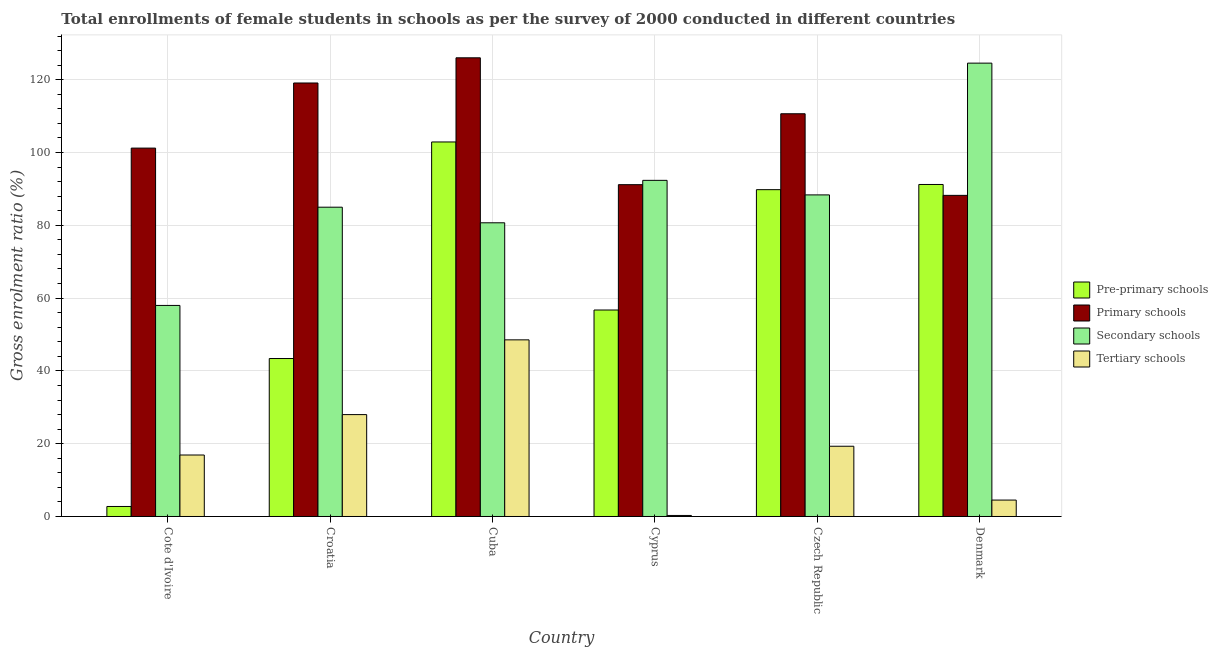How many bars are there on the 5th tick from the right?
Make the answer very short. 4. What is the label of the 4th group of bars from the left?
Offer a terse response. Cyprus. In how many cases, is the number of bars for a given country not equal to the number of legend labels?
Give a very brief answer. 0. What is the gross enrolment ratio(female) in primary schools in Denmark?
Provide a short and direct response. 88.23. Across all countries, what is the maximum gross enrolment ratio(female) in tertiary schools?
Offer a terse response. 48.53. Across all countries, what is the minimum gross enrolment ratio(female) in primary schools?
Your answer should be compact. 88.23. In which country was the gross enrolment ratio(female) in tertiary schools maximum?
Make the answer very short. Cuba. In which country was the gross enrolment ratio(female) in pre-primary schools minimum?
Offer a very short reply. Cote d'Ivoire. What is the total gross enrolment ratio(female) in pre-primary schools in the graph?
Give a very brief answer. 386.79. What is the difference between the gross enrolment ratio(female) in tertiary schools in Cote d'Ivoire and that in Cyprus?
Make the answer very short. 16.61. What is the difference between the gross enrolment ratio(female) in primary schools in Croatia and the gross enrolment ratio(female) in pre-primary schools in Cote d'Ivoire?
Ensure brevity in your answer.  116.36. What is the average gross enrolment ratio(female) in primary schools per country?
Your answer should be very brief. 106.07. What is the difference between the gross enrolment ratio(female) in tertiary schools and gross enrolment ratio(female) in pre-primary schools in Cyprus?
Keep it short and to the point. -56.45. What is the ratio of the gross enrolment ratio(female) in primary schools in Cote d'Ivoire to that in Croatia?
Offer a very short reply. 0.85. What is the difference between the highest and the second highest gross enrolment ratio(female) in secondary schools?
Give a very brief answer. 32.2. What is the difference between the highest and the lowest gross enrolment ratio(female) in tertiary schools?
Give a very brief answer. 48.25. Is the sum of the gross enrolment ratio(female) in pre-primary schools in Cuba and Denmark greater than the maximum gross enrolment ratio(female) in tertiary schools across all countries?
Your answer should be very brief. Yes. Is it the case that in every country, the sum of the gross enrolment ratio(female) in pre-primary schools and gross enrolment ratio(female) in secondary schools is greater than the sum of gross enrolment ratio(female) in tertiary schools and gross enrolment ratio(female) in primary schools?
Make the answer very short. No. What does the 3rd bar from the left in Croatia represents?
Your response must be concise. Secondary schools. What does the 3rd bar from the right in Cuba represents?
Give a very brief answer. Primary schools. How many bars are there?
Make the answer very short. 24. How many countries are there in the graph?
Ensure brevity in your answer.  6. What is the difference between two consecutive major ticks on the Y-axis?
Your answer should be very brief. 20. Are the values on the major ticks of Y-axis written in scientific E-notation?
Make the answer very short. No. Does the graph contain any zero values?
Your answer should be very brief. No. Does the graph contain grids?
Keep it short and to the point. Yes. How are the legend labels stacked?
Offer a very short reply. Vertical. What is the title of the graph?
Keep it short and to the point. Total enrollments of female students in schools as per the survey of 2000 conducted in different countries. Does "WFP" appear as one of the legend labels in the graph?
Ensure brevity in your answer.  No. What is the label or title of the X-axis?
Provide a succinct answer. Country. What is the Gross enrolment ratio (%) of Pre-primary schools in Cote d'Ivoire?
Provide a short and direct response. 2.75. What is the Gross enrolment ratio (%) of Primary schools in Cote d'Ivoire?
Keep it short and to the point. 101.21. What is the Gross enrolment ratio (%) in Secondary schools in Cote d'Ivoire?
Keep it short and to the point. 57.99. What is the Gross enrolment ratio (%) of Tertiary schools in Cote d'Ivoire?
Provide a succinct answer. 16.89. What is the Gross enrolment ratio (%) in Pre-primary schools in Croatia?
Make the answer very short. 43.4. What is the Gross enrolment ratio (%) of Primary schools in Croatia?
Keep it short and to the point. 119.11. What is the Gross enrolment ratio (%) in Secondary schools in Croatia?
Make the answer very short. 84.98. What is the Gross enrolment ratio (%) in Tertiary schools in Croatia?
Keep it short and to the point. 27.99. What is the Gross enrolment ratio (%) of Pre-primary schools in Cuba?
Make the answer very short. 102.9. What is the Gross enrolment ratio (%) of Primary schools in Cuba?
Your answer should be very brief. 126.02. What is the Gross enrolment ratio (%) of Secondary schools in Cuba?
Give a very brief answer. 80.69. What is the Gross enrolment ratio (%) in Tertiary schools in Cuba?
Offer a terse response. 48.53. What is the Gross enrolment ratio (%) of Pre-primary schools in Cyprus?
Give a very brief answer. 56.73. What is the Gross enrolment ratio (%) of Primary schools in Cyprus?
Give a very brief answer. 91.17. What is the Gross enrolment ratio (%) in Secondary schools in Cyprus?
Make the answer very short. 92.35. What is the Gross enrolment ratio (%) of Tertiary schools in Cyprus?
Your response must be concise. 0.28. What is the Gross enrolment ratio (%) of Pre-primary schools in Czech Republic?
Your answer should be compact. 89.8. What is the Gross enrolment ratio (%) of Primary schools in Czech Republic?
Make the answer very short. 110.65. What is the Gross enrolment ratio (%) of Secondary schools in Czech Republic?
Your answer should be very brief. 88.36. What is the Gross enrolment ratio (%) in Tertiary schools in Czech Republic?
Ensure brevity in your answer.  19.3. What is the Gross enrolment ratio (%) in Pre-primary schools in Denmark?
Your answer should be compact. 91.22. What is the Gross enrolment ratio (%) in Primary schools in Denmark?
Give a very brief answer. 88.23. What is the Gross enrolment ratio (%) of Secondary schools in Denmark?
Keep it short and to the point. 124.56. What is the Gross enrolment ratio (%) of Tertiary schools in Denmark?
Ensure brevity in your answer.  4.51. Across all countries, what is the maximum Gross enrolment ratio (%) of Pre-primary schools?
Offer a terse response. 102.9. Across all countries, what is the maximum Gross enrolment ratio (%) of Primary schools?
Offer a terse response. 126.02. Across all countries, what is the maximum Gross enrolment ratio (%) of Secondary schools?
Give a very brief answer. 124.56. Across all countries, what is the maximum Gross enrolment ratio (%) of Tertiary schools?
Provide a succinct answer. 48.53. Across all countries, what is the minimum Gross enrolment ratio (%) of Pre-primary schools?
Offer a very short reply. 2.75. Across all countries, what is the minimum Gross enrolment ratio (%) of Primary schools?
Make the answer very short. 88.23. Across all countries, what is the minimum Gross enrolment ratio (%) of Secondary schools?
Your answer should be very brief. 57.99. Across all countries, what is the minimum Gross enrolment ratio (%) in Tertiary schools?
Offer a terse response. 0.28. What is the total Gross enrolment ratio (%) in Pre-primary schools in the graph?
Provide a succinct answer. 386.79. What is the total Gross enrolment ratio (%) of Primary schools in the graph?
Offer a very short reply. 636.39. What is the total Gross enrolment ratio (%) of Secondary schools in the graph?
Offer a terse response. 528.93. What is the total Gross enrolment ratio (%) of Tertiary schools in the graph?
Provide a short and direct response. 117.51. What is the difference between the Gross enrolment ratio (%) of Pre-primary schools in Cote d'Ivoire and that in Croatia?
Offer a terse response. -40.65. What is the difference between the Gross enrolment ratio (%) of Primary schools in Cote d'Ivoire and that in Croatia?
Provide a succinct answer. -17.89. What is the difference between the Gross enrolment ratio (%) in Secondary schools in Cote d'Ivoire and that in Croatia?
Offer a terse response. -26.99. What is the difference between the Gross enrolment ratio (%) of Tertiary schools in Cote d'Ivoire and that in Croatia?
Your answer should be very brief. -11.1. What is the difference between the Gross enrolment ratio (%) in Pre-primary schools in Cote d'Ivoire and that in Cuba?
Ensure brevity in your answer.  -100.15. What is the difference between the Gross enrolment ratio (%) of Primary schools in Cote d'Ivoire and that in Cuba?
Offer a very short reply. -24.81. What is the difference between the Gross enrolment ratio (%) in Secondary schools in Cote d'Ivoire and that in Cuba?
Your response must be concise. -22.71. What is the difference between the Gross enrolment ratio (%) of Tertiary schools in Cote d'Ivoire and that in Cuba?
Offer a terse response. -31.64. What is the difference between the Gross enrolment ratio (%) in Pre-primary schools in Cote d'Ivoire and that in Cyprus?
Your answer should be very brief. -53.98. What is the difference between the Gross enrolment ratio (%) in Primary schools in Cote d'Ivoire and that in Cyprus?
Your answer should be compact. 10.05. What is the difference between the Gross enrolment ratio (%) of Secondary schools in Cote d'Ivoire and that in Cyprus?
Keep it short and to the point. -34.37. What is the difference between the Gross enrolment ratio (%) of Tertiary schools in Cote d'Ivoire and that in Cyprus?
Your answer should be very brief. 16.61. What is the difference between the Gross enrolment ratio (%) of Pre-primary schools in Cote d'Ivoire and that in Czech Republic?
Your answer should be very brief. -87.05. What is the difference between the Gross enrolment ratio (%) of Primary schools in Cote d'Ivoire and that in Czech Republic?
Provide a succinct answer. -9.44. What is the difference between the Gross enrolment ratio (%) in Secondary schools in Cote d'Ivoire and that in Czech Republic?
Make the answer very short. -30.37. What is the difference between the Gross enrolment ratio (%) of Tertiary schools in Cote d'Ivoire and that in Czech Republic?
Ensure brevity in your answer.  -2.41. What is the difference between the Gross enrolment ratio (%) of Pre-primary schools in Cote d'Ivoire and that in Denmark?
Your answer should be very brief. -88.47. What is the difference between the Gross enrolment ratio (%) of Primary schools in Cote d'Ivoire and that in Denmark?
Your response must be concise. 12.98. What is the difference between the Gross enrolment ratio (%) of Secondary schools in Cote d'Ivoire and that in Denmark?
Your response must be concise. -66.57. What is the difference between the Gross enrolment ratio (%) of Tertiary schools in Cote d'Ivoire and that in Denmark?
Provide a short and direct response. 12.38. What is the difference between the Gross enrolment ratio (%) of Pre-primary schools in Croatia and that in Cuba?
Make the answer very short. -59.5. What is the difference between the Gross enrolment ratio (%) of Primary schools in Croatia and that in Cuba?
Your answer should be very brief. -6.92. What is the difference between the Gross enrolment ratio (%) of Secondary schools in Croatia and that in Cuba?
Your answer should be very brief. 4.28. What is the difference between the Gross enrolment ratio (%) in Tertiary schools in Croatia and that in Cuba?
Your answer should be very brief. -20.54. What is the difference between the Gross enrolment ratio (%) in Pre-primary schools in Croatia and that in Cyprus?
Make the answer very short. -13.33. What is the difference between the Gross enrolment ratio (%) of Primary schools in Croatia and that in Cyprus?
Give a very brief answer. 27.94. What is the difference between the Gross enrolment ratio (%) of Secondary schools in Croatia and that in Cyprus?
Keep it short and to the point. -7.38. What is the difference between the Gross enrolment ratio (%) in Tertiary schools in Croatia and that in Cyprus?
Ensure brevity in your answer.  27.71. What is the difference between the Gross enrolment ratio (%) of Pre-primary schools in Croatia and that in Czech Republic?
Ensure brevity in your answer.  -46.39. What is the difference between the Gross enrolment ratio (%) of Primary schools in Croatia and that in Czech Republic?
Your answer should be compact. 8.45. What is the difference between the Gross enrolment ratio (%) of Secondary schools in Croatia and that in Czech Republic?
Your answer should be very brief. -3.38. What is the difference between the Gross enrolment ratio (%) in Tertiary schools in Croatia and that in Czech Republic?
Ensure brevity in your answer.  8.7. What is the difference between the Gross enrolment ratio (%) of Pre-primary schools in Croatia and that in Denmark?
Provide a short and direct response. -47.82. What is the difference between the Gross enrolment ratio (%) of Primary schools in Croatia and that in Denmark?
Your response must be concise. 30.88. What is the difference between the Gross enrolment ratio (%) of Secondary schools in Croatia and that in Denmark?
Ensure brevity in your answer.  -39.58. What is the difference between the Gross enrolment ratio (%) in Tertiary schools in Croatia and that in Denmark?
Provide a short and direct response. 23.48. What is the difference between the Gross enrolment ratio (%) of Pre-primary schools in Cuba and that in Cyprus?
Give a very brief answer. 46.17. What is the difference between the Gross enrolment ratio (%) of Primary schools in Cuba and that in Cyprus?
Offer a terse response. 34.86. What is the difference between the Gross enrolment ratio (%) of Secondary schools in Cuba and that in Cyprus?
Offer a terse response. -11.66. What is the difference between the Gross enrolment ratio (%) of Tertiary schools in Cuba and that in Cyprus?
Your answer should be compact. 48.25. What is the difference between the Gross enrolment ratio (%) of Pre-primary schools in Cuba and that in Czech Republic?
Provide a succinct answer. 13.1. What is the difference between the Gross enrolment ratio (%) in Primary schools in Cuba and that in Czech Republic?
Make the answer very short. 15.37. What is the difference between the Gross enrolment ratio (%) in Secondary schools in Cuba and that in Czech Republic?
Your answer should be very brief. -7.66. What is the difference between the Gross enrolment ratio (%) in Tertiary schools in Cuba and that in Czech Republic?
Provide a short and direct response. 29.23. What is the difference between the Gross enrolment ratio (%) in Pre-primary schools in Cuba and that in Denmark?
Offer a very short reply. 11.68. What is the difference between the Gross enrolment ratio (%) of Primary schools in Cuba and that in Denmark?
Your answer should be very brief. 37.79. What is the difference between the Gross enrolment ratio (%) of Secondary schools in Cuba and that in Denmark?
Your answer should be compact. -43.86. What is the difference between the Gross enrolment ratio (%) in Tertiary schools in Cuba and that in Denmark?
Ensure brevity in your answer.  44.02. What is the difference between the Gross enrolment ratio (%) in Pre-primary schools in Cyprus and that in Czech Republic?
Make the answer very short. -33.06. What is the difference between the Gross enrolment ratio (%) of Primary schools in Cyprus and that in Czech Republic?
Offer a very short reply. -19.48. What is the difference between the Gross enrolment ratio (%) of Secondary schools in Cyprus and that in Czech Republic?
Your answer should be very brief. 4. What is the difference between the Gross enrolment ratio (%) of Tertiary schools in Cyprus and that in Czech Republic?
Ensure brevity in your answer.  -19.02. What is the difference between the Gross enrolment ratio (%) of Pre-primary schools in Cyprus and that in Denmark?
Ensure brevity in your answer.  -34.49. What is the difference between the Gross enrolment ratio (%) of Primary schools in Cyprus and that in Denmark?
Give a very brief answer. 2.94. What is the difference between the Gross enrolment ratio (%) of Secondary schools in Cyprus and that in Denmark?
Offer a very short reply. -32.2. What is the difference between the Gross enrolment ratio (%) of Tertiary schools in Cyprus and that in Denmark?
Your response must be concise. -4.23. What is the difference between the Gross enrolment ratio (%) of Pre-primary schools in Czech Republic and that in Denmark?
Give a very brief answer. -1.42. What is the difference between the Gross enrolment ratio (%) of Primary schools in Czech Republic and that in Denmark?
Your response must be concise. 22.42. What is the difference between the Gross enrolment ratio (%) in Secondary schools in Czech Republic and that in Denmark?
Your answer should be very brief. -36.2. What is the difference between the Gross enrolment ratio (%) of Tertiary schools in Czech Republic and that in Denmark?
Provide a short and direct response. 14.79. What is the difference between the Gross enrolment ratio (%) in Pre-primary schools in Cote d'Ivoire and the Gross enrolment ratio (%) in Primary schools in Croatia?
Offer a terse response. -116.36. What is the difference between the Gross enrolment ratio (%) of Pre-primary schools in Cote d'Ivoire and the Gross enrolment ratio (%) of Secondary schools in Croatia?
Keep it short and to the point. -82.23. What is the difference between the Gross enrolment ratio (%) of Pre-primary schools in Cote d'Ivoire and the Gross enrolment ratio (%) of Tertiary schools in Croatia?
Make the answer very short. -25.25. What is the difference between the Gross enrolment ratio (%) in Primary schools in Cote d'Ivoire and the Gross enrolment ratio (%) in Secondary schools in Croatia?
Make the answer very short. 16.24. What is the difference between the Gross enrolment ratio (%) in Primary schools in Cote d'Ivoire and the Gross enrolment ratio (%) in Tertiary schools in Croatia?
Keep it short and to the point. 73.22. What is the difference between the Gross enrolment ratio (%) of Secondary schools in Cote d'Ivoire and the Gross enrolment ratio (%) of Tertiary schools in Croatia?
Give a very brief answer. 29.99. What is the difference between the Gross enrolment ratio (%) of Pre-primary schools in Cote d'Ivoire and the Gross enrolment ratio (%) of Primary schools in Cuba?
Your answer should be very brief. -123.27. What is the difference between the Gross enrolment ratio (%) in Pre-primary schools in Cote d'Ivoire and the Gross enrolment ratio (%) in Secondary schools in Cuba?
Offer a very short reply. -77.95. What is the difference between the Gross enrolment ratio (%) in Pre-primary schools in Cote d'Ivoire and the Gross enrolment ratio (%) in Tertiary schools in Cuba?
Your answer should be compact. -45.78. What is the difference between the Gross enrolment ratio (%) in Primary schools in Cote d'Ivoire and the Gross enrolment ratio (%) in Secondary schools in Cuba?
Your response must be concise. 20.52. What is the difference between the Gross enrolment ratio (%) in Primary schools in Cote d'Ivoire and the Gross enrolment ratio (%) in Tertiary schools in Cuba?
Your response must be concise. 52.68. What is the difference between the Gross enrolment ratio (%) in Secondary schools in Cote d'Ivoire and the Gross enrolment ratio (%) in Tertiary schools in Cuba?
Ensure brevity in your answer.  9.46. What is the difference between the Gross enrolment ratio (%) in Pre-primary schools in Cote d'Ivoire and the Gross enrolment ratio (%) in Primary schools in Cyprus?
Ensure brevity in your answer.  -88.42. What is the difference between the Gross enrolment ratio (%) of Pre-primary schools in Cote d'Ivoire and the Gross enrolment ratio (%) of Secondary schools in Cyprus?
Offer a terse response. -89.61. What is the difference between the Gross enrolment ratio (%) of Pre-primary schools in Cote d'Ivoire and the Gross enrolment ratio (%) of Tertiary schools in Cyprus?
Provide a short and direct response. 2.47. What is the difference between the Gross enrolment ratio (%) of Primary schools in Cote d'Ivoire and the Gross enrolment ratio (%) of Secondary schools in Cyprus?
Offer a very short reply. 8.86. What is the difference between the Gross enrolment ratio (%) of Primary schools in Cote d'Ivoire and the Gross enrolment ratio (%) of Tertiary schools in Cyprus?
Give a very brief answer. 100.93. What is the difference between the Gross enrolment ratio (%) in Secondary schools in Cote d'Ivoire and the Gross enrolment ratio (%) in Tertiary schools in Cyprus?
Offer a terse response. 57.71. What is the difference between the Gross enrolment ratio (%) of Pre-primary schools in Cote d'Ivoire and the Gross enrolment ratio (%) of Primary schools in Czech Republic?
Ensure brevity in your answer.  -107.9. What is the difference between the Gross enrolment ratio (%) in Pre-primary schools in Cote d'Ivoire and the Gross enrolment ratio (%) in Secondary schools in Czech Republic?
Keep it short and to the point. -85.61. What is the difference between the Gross enrolment ratio (%) in Pre-primary schools in Cote d'Ivoire and the Gross enrolment ratio (%) in Tertiary schools in Czech Republic?
Ensure brevity in your answer.  -16.55. What is the difference between the Gross enrolment ratio (%) in Primary schools in Cote d'Ivoire and the Gross enrolment ratio (%) in Secondary schools in Czech Republic?
Provide a succinct answer. 12.86. What is the difference between the Gross enrolment ratio (%) of Primary schools in Cote d'Ivoire and the Gross enrolment ratio (%) of Tertiary schools in Czech Republic?
Provide a succinct answer. 81.92. What is the difference between the Gross enrolment ratio (%) in Secondary schools in Cote d'Ivoire and the Gross enrolment ratio (%) in Tertiary schools in Czech Republic?
Give a very brief answer. 38.69. What is the difference between the Gross enrolment ratio (%) in Pre-primary schools in Cote d'Ivoire and the Gross enrolment ratio (%) in Primary schools in Denmark?
Provide a succinct answer. -85.48. What is the difference between the Gross enrolment ratio (%) of Pre-primary schools in Cote d'Ivoire and the Gross enrolment ratio (%) of Secondary schools in Denmark?
Offer a very short reply. -121.81. What is the difference between the Gross enrolment ratio (%) in Pre-primary schools in Cote d'Ivoire and the Gross enrolment ratio (%) in Tertiary schools in Denmark?
Give a very brief answer. -1.76. What is the difference between the Gross enrolment ratio (%) in Primary schools in Cote d'Ivoire and the Gross enrolment ratio (%) in Secondary schools in Denmark?
Your response must be concise. -23.34. What is the difference between the Gross enrolment ratio (%) of Primary schools in Cote d'Ivoire and the Gross enrolment ratio (%) of Tertiary schools in Denmark?
Offer a very short reply. 96.7. What is the difference between the Gross enrolment ratio (%) of Secondary schools in Cote d'Ivoire and the Gross enrolment ratio (%) of Tertiary schools in Denmark?
Your response must be concise. 53.48. What is the difference between the Gross enrolment ratio (%) in Pre-primary schools in Croatia and the Gross enrolment ratio (%) in Primary schools in Cuba?
Your response must be concise. -82.62. What is the difference between the Gross enrolment ratio (%) in Pre-primary schools in Croatia and the Gross enrolment ratio (%) in Secondary schools in Cuba?
Keep it short and to the point. -37.29. What is the difference between the Gross enrolment ratio (%) of Pre-primary schools in Croatia and the Gross enrolment ratio (%) of Tertiary schools in Cuba?
Give a very brief answer. -5.13. What is the difference between the Gross enrolment ratio (%) of Primary schools in Croatia and the Gross enrolment ratio (%) of Secondary schools in Cuba?
Your response must be concise. 38.41. What is the difference between the Gross enrolment ratio (%) in Primary schools in Croatia and the Gross enrolment ratio (%) in Tertiary schools in Cuba?
Offer a terse response. 70.57. What is the difference between the Gross enrolment ratio (%) of Secondary schools in Croatia and the Gross enrolment ratio (%) of Tertiary schools in Cuba?
Offer a terse response. 36.45. What is the difference between the Gross enrolment ratio (%) in Pre-primary schools in Croatia and the Gross enrolment ratio (%) in Primary schools in Cyprus?
Your response must be concise. -47.77. What is the difference between the Gross enrolment ratio (%) of Pre-primary schools in Croatia and the Gross enrolment ratio (%) of Secondary schools in Cyprus?
Your answer should be very brief. -48.95. What is the difference between the Gross enrolment ratio (%) in Pre-primary schools in Croatia and the Gross enrolment ratio (%) in Tertiary schools in Cyprus?
Ensure brevity in your answer.  43.12. What is the difference between the Gross enrolment ratio (%) in Primary schools in Croatia and the Gross enrolment ratio (%) in Secondary schools in Cyprus?
Offer a very short reply. 26.75. What is the difference between the Gross enrolment ratio (%) in Primary schools in Croatia and the Gross enrolment ratio (%) in Tertiary schools in Cyprus?
Offer a very short reply. 118.82. What is the difference between the Gross enrolment ratio (%) in Secondary schools in Croatia and the Gross enrolment ratio (%) in Tertiary schools in Cyprus?
Your answer should be very brief. 84.7. What is the difference between the Gross enrolment ratio (%) of Pre-primary schools in Croatia and the Gross enrolment ratio (%) of Primary schools in Czech Republic?
Your answer should be very brief. -67.25. What is the difference between the Gross enrolment ratio (%) of Pre-primary schools in Croatia and the Gross enrolment ratio (%) of Secondary schools in Czech Republic?
Ensure brevity in your answer.  -44.96. What is the difference between the Gross enrolment ratio (%) of Pre-primary schools in Croatia and the Gross enrolment ratio (%) of Tertiary schools in Czech Republic?
Provide a succinct answer. 24.1. What is the difference between the Gross enrolment ratio (%) in Primary schools in Croatia and the Gross enrolment ratio (%) in Secondary schools in Czech Republic?
Offer a terse response. 30.75. What is the difference between the Gross enrolment ratio (%) in Primary schools in Croatia and the Gross enrolment ratio (%) in Tertiary schools in Czech Republic?
Give a very brief answer. 99.81. What is the difference between the Gross enrolment ratio (%) in Secondary schools in Croatia and the Gross enrolment ratio (%) in Tertiary schools in Czech Republic?
Ensure brevity in your answer.  65.68. What is the difference between the Gross enrolment ratio (%) of Pre-primary schools in Croatia and the Gross enrolment ratio (%) of Primary schools in Denmark?
Provide a succinct answer. -44.83. What is the difference between the Gross enrolment ratio (%) of Pre-primary schools in Croatia and the Gross enrolment ratio (%) of Secondary schools in Denmark?
Your answer should be very brief. -81.16. What is the difference between the Gross enrolment ratio (%) in Pre-primary schools in Croatia and the Gross enrolment ratio (%) in Tertiary schools in Denmark?
Your answer should be compact. 38.89. What is the difference between the Gross enrolment ratio (%) of Primary schools in Croatia and the Gross enrolment ratio (%) of Secondary schools in Denmark?
Give a very brief answer. -5.45. What is the difference between the Gross enrolment ratio (%) in Primary schools in Croatia and the Gross enrolment ratio (%) in Tertiary schools in Denmark?
Offer a terse response. 114.59. What is the difference between the Gross enrolment ratio (%) in Secondary schools in Croatia and the Gross enrolment ratio (%) in Tertiary schools in Denmark?
Your response must be concise. 80.47. What is the difference between the Gross enrolment ratio (%) in Pre-primary schools in Cuba and the Gross enrolment ratio (%) in Primary schools in Cyprus?
Provide a succinct answer. 11.73. What is the difference between the Gross enrolment ratio (%) of Pre-primary schools in Cuba and the Gross enrolment ratio (%) of Secondary schools in Cyprus?
Provide a short and direct response. 10.55. What is the difference between the Gross enrolment ratio (%) in Pre-primary schools in Cuba and the Gross enrolment ratio (%) in Tertiary schools in Cyprus?
Ensure brevity in your answer.  102.62. What is the difference between the Gross enrolment ratio (%) in Primary schools in Cuba and the Gross enrolment ratio (%) in Secondary schools in Cyprus?
Make the answer very short. 33.67. What is the difference between the Gross enrolment ratio (%) in Primary schools in Cuba and the Gross enrolment ratio (%) in Tertiary schools in Cyprus?
Offer a very short reply. 125.74. What is the difference between the Gross enrolment ratio (%) of Secondary schools in Cuba and the Gross enrolment ratio (%) of Tertiary schools in Cyprus?
Ensure brevity in your answer.  80.41. What is the difference between the Gross enrolment ratio (%) in Pre-primary schools in Cuba and the Gross enrolment ratio (%) in Primary schools in Czech Republic?
Your answer should be compact. -7.75. What is the difference between the Gross enrolment ratio (%) in Pre-primary schools in Cuba and the Gross enrolment ratio (%) in Secondary schools in Czech Republic?
Give a very brief answer. 14.54. What is the difference between the Gross enrolment ratio (%) in Pre-primary schools in Cuba and the Gross enrolment ratio (%) in Tertiary schools in Czech Republic?
Your answer should be very brief. 83.6. What is the difference between the Gross enrolment ratio (%) of Primary schools in Cuba and the Gross enrolment ratio (%) of Secondary schools in Czech Republic?
Keep it short and to the point. 37.67. What is the difference between the Gross enrolment ratio (%) of Primary schools in Cuba and the Gross enrolment ratio (%) of Tertiary schools in Czech Republic?
Make the answer very short. 106.72. What is the difference between the Gross enrolment ratio (%) of Secondary schools in Cuba and the Gross enrolment ratio (%) of Tertiary schools in Czech Republic?
Make the answer very short. 61.4. What is the difference between the Gross enrolment ratio (%) of Pre-primary schools in Cuba and the Gross enrolment ratio (%) of Primary schools in Denmark?
Your answer should be compact. 14.67. What is the difference between the Gross enrolment ratio (%) of Pre-primary schools in Cuba and the Gross enrolment ratio (%) of Secondary schools in Denmark?
Offer a terse response. -21.66. What is the difference between the Gross enrolment ratio (%) of Pre-primary schools in Cuba and the Gross enrolment ratio (%) of Tertiary schools in Denmark?
Offer a terse response. 98.39. What is the difference between the Gross enrolment ratio (%) in Primary schools in Cuba and the Gross enrolment ratio (%) in Secondary schools in Denmark?
Give a very brief answer. 1.46. What is the difference between the Gross enrolment ratio (%) in Primary schools in Cuba and the Gross enrolment ratio (%) in Tertiary schools in Denmark?
Make the answer very short. 121.51. What is the difference between the Gross enrolment ratio (%) of Secondary schools in Cuba and the Gross enrolment ratio (%) of Tertiary schools in Denmark?
Your response must be concise. 76.18. What is the difference between the Gross enrolment ratio (%) of Pre-primary schools in Cyprus and the Gross enrolment ratio (%) of Primary schools in Czech Republic?
Your response must be concise. -53.92. What is the difference between the Gross enrolment ratio (%) of Pre-primary schools in Cyprus and the Gross enrolment ratio (%) of Secondary schools in Czech Republic?
Give a very brief answer. -31.63. What is the difference between the Gross enrolment ratio (%) in Pre-primary schools in Cyprus and the Gross enrolment ratio (%) in Tertiary schools in Czech Republic?
Your answer should be compact. 37.43. What is the difference between the Gross enrolment ratio (%) in Primary schools in Cyprus and the Gross enrolment ratio (%) in Secondary schools in Czech Republic?
Ensure brevity in your answer.  2.81. What is the difference between the Gross enrolment ratio (%) of Primary schools in Cyprus and the Gross enrolment ratio (%) of Tertiary schools in Czech Republic?
Give a very brief answer. 71.87. What is the difference between the Gross enrolment ratio (%) of Secondary schools in Cyprus and the Gross enrolment ratio (%) of Tertiary schools in Czech Republic?
Provide a short and direct response. 73.05. What is the difference between the Gross enrolment ratio (%) in Pre-primary schools in Cyprus and the Gross enrolment ratio (%) in Primary schools in Denmark?
Your response must be concise. -31.5. What is the difference between the Gross enrolment ratio (%) in Pre-primary schools in Cyprus and the Gross enrolment ratio (%) in Secondary schools in Denmark?
Offer a terse response. -67.83. What is the difference between the Gross enrolment ratio (%) of Pre-primary schools in Cyprus and the Gross enrolment ratio (%) of Tertiary schools in Denmark?
Offer a terse response. 52.22. What is the difference between the Gross enrolment ratio (%) in Primary schools in Cyprus and the Gross enrolment ratio (%) in Secondary schools in Denmark?
Provide a succinct answer. -33.39. What is the difference between the Gross enrolment ratio (%) in Primary schools in Cyprus and the Gross enrolment ratio (%) in Tertiary schools in Denmark?
Your response must be concise. 86.66. What is the difference between the Gross enrolment ratio (%) in Secondary schools in Cyprus and the Gross enrolment ratio (%) in Tertiary schools in Denmark?
Your answer should be compact. 87.84. What is the difference between the Gross enrolment ratio (%) in Pre-primary schools in Czech Republic and the Gross enrolment ratio (%) in Primary schools in Denmark?
Give a very brief answer. 1.57. What is the difference between the Gross enrolment ratio (%) of Pre-primary schools in Czech Republic and the Gross enrolment ratio (%) of Secondary schools in Denmark?
Keep it short and to the point. -34.76. What is the difference between the Gross enrolment ratio (%) of Pre-primary schools in Czech Republic and the Gross enrolment ratio (%) of Tertiary schools in Denmark?
Provide a short and direct response. 85.28. What is the difference between the Gross enrolment ratio (%) of Primary schools in Czech Republic and the Gross enrolment ratio (%) of Secondary schools in Denmark?
Your answer should be very brief. -13.91. What is the difference between the Gross enrolment ratio (%) in Primary schools in Czech Republic and the Gross enrolment ratio (%) in Tertiary schools in Denmark?
Keep it short and to the point. 106.14. What is the difference between the Gross enrolment ratio (%) in Secondary schools in Czech Republic and the Gross enrolment ratio (%) in Tertiary schools in Denmark?
Provide a short and direct response. 83.84. What is the average Gross enrolment ratio (%) in Pre-primary schools per country?
Keep it short and to the point. 64.47. What is the average Gross enrolment ratio (%) in Primary schools per country?
Your answer should be compact. 106.07. What is the average Gross enrolment ratio (%) in Secondary schools per country?
Provide a succinct answer. 88.15. What is the average Gross enrolment ratio (%) in Tertiary schools per country?
Provide a succinct answer. 19.58. What is the difference between the Gross enrolment ratio (%) of Pre-primary schools and Gross enrolment ratio (%) of Primary schools in Cote d'Ivoire?
Offer a very short reply. -98.47. What is the difference between the Gross enrolment ratio (%) in Pre-primary schools and Gross enrolment ratio (%) in Secondary schools in Cote d'Ivoire?
Offer a terse response. -55.24. What is the difference between the Gross enrolment ratio (%) in Pre-primary schools and Gross enrolment ratio (%) in Tertiary schools in Cote d'Ivoire?
Your answer should be very brief. -14.14. What is the difference between the Gross enrolment ratio (%) of Primary schools and Gross enrolment ratio (%) of Secondary schools in Cote d'Ivoire?
Offer a very short reply. 43.23. What is the difference between the Gross enrolment ratio (%) in Primary schools and Gross enrolment ratio (%) in Tertiary schools in Cote d'Ivoire?
Make the answer very short. 84.32. What is the difference between the Gross enrolment ratio (%) in Secondary schools and Gross enrolment ratio (%) in Tertiary schools in Cote d'Ivoire?
Your answer should be very brief. 41.1. What is the difference between the Gross enrolment ratio (%) in Pre-primary schools and Gross enrolment ratio (%) in Primary schools in Croatia?
Ensure brevity in your answer.  -75.7. What is the difference between the Gross enrolment ratio (%) in Pre-primary schools and Gross enrolment ratio (%) in Secondary schools in Croatia?
Offer a terse response. -41.58. What is the difference between the Gross enrolment ratio (%) of Pre-primary schools and Gross enrolment ratio (%) of Tertiary schools in Croatia?
Your answer should be compact. 15.41. What is the difference between the Gross enrolment ratio (%) in Primary schools and Gross enrolment ratio (%) in Secondary schools in Croatia?
Your answer should be very brief. 34.13. What is the difference between the Gross enrolment ratio (%) of Primary schools and Gross enrolment ratio (%) of Tertiary schools in Croatia?
Your response must be concise. 91.11. What is the difference between the Gross enrolment ratio (%) of Secondary schools and Gross enrolment ratio (%) of Tertiary schools in Croatia?
Provide a succinct answer. 56.98. What is the difference between the Gross enrolment ratio (%) in Pre-primary schools and Gross enrolment ratio (%) in Primary schools in Cuba?
Give a very brief answer. -23.12. What is the difference between the Gross enrolment ratio (%) of Pre-primary schools and Gross enrolment ratio (%) of Secondary schools in Cuba?
Provide a short and direct response. 22.21. What is the difference between the Gross enrolment ratio (%) of Pre-primary schools and Gross enrolment ratio (%) of Tertiary schools in Cuba?
Provide a succinct answer. 54.37. What is the difference between the Gross enrolment ratio (%) of Primary schools and Gross enrolment ratio (%) of Secondary schools in Cuba?
Offer a very short reply. 45.33. What is the difference between the Gross enrolment ratio (%) in Primary schools and Gross enrolment ratio (%) in Tertiary schools in Cuba?
Your answer should be very brief. 77.49. What is the difference between the Gross enrolment ratio (%) of Secondary schools and Gross enrolment ratio (%) of Tertiary schools in Cuba?
Make the answer very short. 32.16. What is the difference between the Gross enrolment ratio (%) in Pre-primary schools and Gross enrolment ratio (%) in Primary schools in Cyprus?
Your answer should be very brief. -34.44. What is the difference between the Gross enrolment ratio (%) in Pre-primary schools and Gross enrolment ratio (%) in Secondary schools in Cyprus?
Your answer should be very brief. -35.62. What is the difference between the Gross enrolment ratio (%) of Pre-primary schools and Gross enrolment ratio (%) of Tertiary schools in Cyprus?
Your response must be concise. 56.45. What is the difference between the Gross enrolment ratio (%) of Primary schools and Gross enrolment ratio (%) of Secondary schools in Cyprus?
Give a very brief answer. -1.19. What is the difference between the Gross enrolment ratio (%) in Primary schools and Gross enrolment ratio (%) in Tertiary schools in Cyprus?
Keep it short and to the point. 90.88. What is the difference between the Gross enrolment ratio (%) in Secondary schools and Gross enrolment ratio (%) in Tertiary schools in Cyprus?
Your answer should be compact. 92.07. What is the difference between the Gross enrolment ratio (%) of Pre-primary schools and Gross enrolment ratio (%) of Primary schools in Czech Republic?
Keep it short and to the point. -20.86. What is the difference between the Gross enrolment ratio (%) of Pre-primary schools and Gross enrolment ratio (%) of Secondary schools in Czech Republic?
Give a very brief answer. 1.44. What is the difference between the Gross enrolment ratio (%) in Pre-primary schools and Gross enrolment ratio (%) in Tertiary schools in Czech Republic?
Offer a terse response. 70.5. What is the difference between the Gross enrolment ratio (%) of Primary schools and Gross enrolment ratio (%) of Secondary schools in Czech Republic?
Your response must be concise. 22.3. What is the difference between the Gross enrolment ratio (%) of Primary schools and Gross enrolment ratio (%) of Tertiary schools in Czech Republic?
Provide a short and direct response. 91.35. What is the difference between the Gross enrolment ratio (%) in Secondary schools and Gross enrolment ratio (%) in Tertiary schools in Czech Republic?
Ensure brevity in your answer.  69.06. What is the difference between the Gross enrolment ratio (%) in Pre-primary schools and Gross enrolment ratio (%) in Primary schools in Denmark?
Your answer should be very brief. 2.99. What is the difference between the Gross enrolment ratio (%) of Pre-primary schools and Gross enrolment ratio (%) of Secondary schools in Denmark?
Keep it short and to the point. -33.34. What is the difference between the Gross enrolment ratio (%) of Pre-primary schools and Gross enrolment ratio (%) of Tertiary schools in Denmark?
Keep it short and to the point. 86.71. What is the difference between the Gross enrolment ratio (%) of Primary schools and Gross enrolment ratio (%) of Secondary schools in Denmark?
Your answer should be very brief. -36.33. What is the difference between the Gross enrolment ratio (%) of Primary schools and Gross enrolment ratio (%) of Tertiary schools in Denmark?
Provide a short and direct response. 83.72. What is the difference between the Gross enrolment ratio (%) in Secondary schools and Gross enrolment ratio (%) in Tertiary schools in Denmark?
Give a very brief answer. 120.05. What is the ratio of the Gross enrolment ratio (%) in Pre-primary schools in Cote d'Ivoire to that in Croatia?
Your answer should be very brief. 0.06. What is the ratio of the Gross enrolment ratio (%) of Primary schools in Cote d'Ivoire to that in Croatia?
Your answer should be compact. 0.85. What is the ratio of the Gross enrolment ratio (%) in Secondary schools in Cote d'Ivoire to that in Croatia?
Make the answer very short. 0.68. What is the ratio of the Gross enrolment ratio (%) in Tertiary schools in Cote d'Ivoire to that in Croatia?
Give a very brief answer. 0.6. What is the ratio of the Gross enrolment ratio (%) of Pre-primary schools in Cote d'Ivoire to that in Cuba?
Ensure brevity in your answer.  0.03. What is the ratio of the Gross enrolment ratio (%) in Primary schools in Cote d'Ivoire to that in Cuba?
Your answer should be very brief. 0.8. What is the ratio of the Gross enrolment ratio (%) of Secondary schools in Cote d'Ivoire to that in Cuba?
Offer a very short reply. 0.72. What is the ratio of the Gross enrolment ratio (%) in Tertiary schools in Cote d'Ivoire to that in Cuba?
Offer a terse response. 0.35. What is the ratio of the Gross enrolment ratio (%) of Pre-primary schools in Cote d'Ivoire to that in Cyprus?
Make the answer very short. 0.05. What is the ratio of the Gross enrolment ratio (%) in Primary schools in Cote d'Ivoire to that in Cyprus?
Your answer should be very brief. 1.11. What is the ratio of the Gross enrolment ratio (%) in Secondary schools in Cote d'Ivoire to that in Cyprus?
Your response must be concise. 0.63. What is the ratio of the Gross enrolment ratio (%) in Tertiary schools in Cote d'Ivoire to that in Cyprus?
Give a very brief answer. 59.81. What is the ratio of the Gross enrolment ratio (%) in Pre-primary schools in Cote d'Ivoire to that in Czech Republic?
Your response must be concise. 0.03. What is the ratio of the Gross enrolment ratio (%) in Primary schools in Cote d'Ivoire to that in Czech Republic?
Provide a succinct answer. 0.91. What is the ratio of the Gross enrolment ratio (%) of Secondary schools in Cote d'Ivoire to that in Czech Republic?
Provide a short and direct response. 0.66. What is the ratio of the Gross enrolment ratio (%) in Tertiary schools in Cote d'Ivoire to that in Czech Republic?
Ensure brevity in your answer.  0.88. What is the ratio of the Gross enrolment ratio (%) in Pre-primary schools in Cote d'Ivoire to that in Denmark?
Provide a succinct answer. 0.03. What is the ratio of the Gross enrolment ratio (%) in Primary schools in Cote d'Ivoire to that in Denmark?
Your answer should be compact. 1.15. What is the ratio of the Gross enrolment ratio (%) of Secondary schools in Cote d'Ivoire to that in Denmark?
Make the answer very short. 0.47. What is the ratio of the Gross enrolment ratio (%) in Tertiary schools in Cote d'Ivoire to that in Denmark?
Your response must be concise. 3.74. What is the ratio of the Gross enrolment ratio (%) of Pre-primary schools in Croatia to that in Cuba?
Your answer should be compact. 0.42. What is the ratio of the Gross enrolment ratio (%) of Primary schools in Croatia to that in Cuba?
Your answer should be compact. 0.95. What is the ratio of the Gross enrolment ratio (%) of Secondary schools in Croatia to that in Cuba?
Offer a terse response. 1.05. What is the ratio of the Gross enrolment ratio (%) in Tertiary schools in Croatia to that in Cuba?
Your response must be concise. 0.58. What is the ratio of the Gross enrolment ratio (%) of Pre-primary schools in Croatia to that in Cyprus?
Your answer should be compact. 0.77. What is the ratio of the Gross enrolment ratio (%) in Primary schools in Croatia to that in Cyprus?
Your response must be concise. 1.31. What is the ratio of the Gross enrolment ratio (%) in Secondary schools in Croatia to that in Cyprus?
Make the answer very short. 0.92. What is the ratio of the Gross enrolment ratio (%) in Tertiary schools in Croatia to that in Cyprus?
Provide a succinct answer. 99.13. What is the ratio of the Gross enrolment ratio (%) of Pre-primary schools in Croatia to that in Czech Republic?
Make the answer very short. 0.48. What is the ratio of the Gross enrolment ratio (%) of Primary schools in Croatia to that in Czech Republic?
Keep it short and to the point. 1.08. What is the ratio of the Gross enrolment ratio (%) in Secondary schools in Croatia to that in Czech Republic?
Your answer should be very brief. 0.96. What is the ratio of the Gross enrolment ratio (%) of Tertiary schools in Croatia to that in Czech Republic?
Give a very brief answer. 1.45. What is the ratio of the Gross enrolment ratio (%) in Pre-primary schools in Croatia to that in Denmark?
Offer a very short reply. 0.48. What is the ratio of the Gross enrolment ratio (%) of Primary schools in Croatia to that in Denmark?
Your answer should be very brief. 1.35. What is the ratio of the Gross enrolment ratio (%) in Secondary schools in Croatia to that in Denmark?
Provide a short and direct response. 0.68. What is the ratio of the Gross enrolment ratio (%) in Tertiary schools in Croatia to that in Denmark?
Your answer should be very brief. 6.21. What is the ratio of the Gross enrolment ratio (%) of Pre-primary schools in Cuba to that in Cyprus?
Ensure brevity in your answer.  1.81. What is the ratio of the Gross enrolment ratio (%) of Primary schools in Cuba to that in Cyprus?
Make the answer very short. 1.38. What is the ratio of the Gross enrolment ratio (%) of Secondary schools in Cuba to that in Cyprus?
Your answer should be compact. 0.87. What is the ratio of the Gross enrolment ratio (%) of Tertiary schools in Cuba to that in Cyprus?
Ensure brevity in your answer.  171.85. What is the ratio of the Gross enrolment ratio (%) in Pre-primary schools in Cuba to that in Czech Republic?
Your response must be concise. 1.15. What is the ratio of the Gross enrolment ratio (%) in Primary schools in Cuba to that in Czech Republic?
Give a very brief answer. 1.14. What is the ratio of the Gross enrolment ratio (%) of Secondary schools in Cuba to that in Czech Republic?
Keep it short and to the point. 0.91. What is the ratio of the Gross enrolment ratio (%) in Tertiary schools in Cuba to that in Czech Republic?
Give a very brief answer. 2.51. What is the ratio of the Gross enrolment ratio (%) in Pre-primary schools in Cuba to that in Denmark?
Ensure brevity in your answer.  1.13. What is the ratio of the Gross enrolment ratio (%) of Primary schools in Cuba to that in Denmark?
Your answer should be compact. 1.43. What is the ratio of the Gross enrolment ratio (%) of Secondary schools in Cuba to that in Denmark?
Offer a terse response. 0.65. What is the ratio of the Gross enrolment ratio (%) in Tertiary schools in Cuba to that in Denmark?
Keep it short and to the point. 10.76. What is the ratio of the Gross enrolment ratio (%) in Pre-primary schools in Cyprus to that in Czech Republic?
Your answer should be very brief. 0.63. What is the ratio of the Gross enrolment ratio (%) of Primary schools in Cyprus to that in Czech Republic?
Offer a terse response. 0.82. What is the ratio of the Gross enrolment ratio (%) in Secondary schools in Cyprus to that in Czech Republic?
Your answer should be very brief. 1.05. What is the ratio of the Gross enrolment ratio (%) of Tertiary schools in Cyprus to that in Czech Republic?
Your response must be concise. 0.01. What is the ratio of the Gross enrolment ratio (%) in Pre-primary schools in Cyprus to that in Denmark?
Your answer should be compact. 0.62. What is the ratio of the Gross enrolment ratio (%) in Secondary schools in Cyprus to that in Denmark?
Offer a very short reply. 0.74. What is the ratio of the Gross enrolment ratio (%) of Tertiary schools in Cyprus to that in Denmark?
Make the answer very short. 0.06. What is the ratio of the Gross enrolment ratio (%) of Pre-primary schools in Czech Republic to that in Denmark?
Provide a short and direct response. 0.98. What is the ratio of the Gross enrolment ratio (%) of Primary schools in Czech Republic to that in Denmark?
Ensure brevity in your answer.  1.25. What is the ratio of the Gross enrolment ratio (%) in Secondary schools in Czech Republic to that in Denmark?
Keep it short and to the point. 0.71. What is the ratio of the Gross enrolment ratio (%) in Tertiary schools in Czech Republic to that in Denmark?
Ensure brevity in your answer.  4.28. What is the difference between the highest and the second highest Gross enrolment ratio (%) of Pre-primary schools?
Offer a terse response. 11.68. What is the difference between the highest and the second highest Gross enrolment ratio (%) in Primary schools?
Offer a very short reply. 6.92. What is the difference between the highest and the second highest Gross enrolment ratio (%) of Secondary schools?
Ensure brevity in your answer.  32.2. What is the difference between the highest and the second highest Gross enrolment ratio (%) of Tertiary schools?
Your answer should be very brief. 20.54. What is the difference between the highest and the lowest Gross enrolment ratio (%) of Pre-primary schools?
Your answer should be compact. 100.15. What is the difference between the highest and the lowest Gross enrolment ratio (%) of Primary schools?
Your answer should be very brief. 37.79. What is the difference between the highest and the lowest Gross enrolment ratio (%) in Secondary schools?
Your answer should be very brief. 66.57. What is the difference between the highest and the lowest Gross enrolment ratio (%) in Tertiary schools?
Keep it short and to the point. 48.25. 